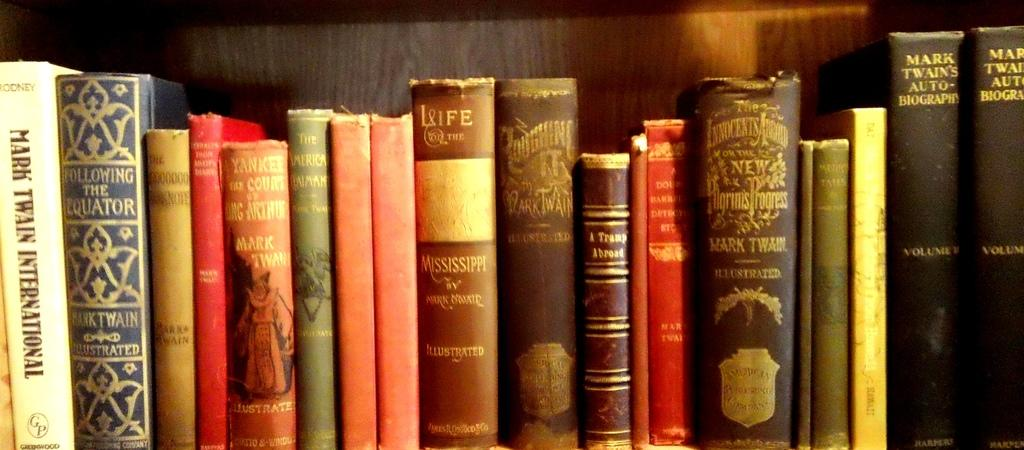<image>
Present a compact description of the photo's key features. A row of books including Mark Twain's autobiography. 